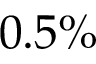Convert formula to latex. <formula><loc_0><loc_0><loc_500><loc_500>0 . 5 \%</formula> 